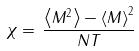Convert formula to latex. <formula><loc_0><loc_0><loc_500><loc_500>\chi = \, \frac { \left < M ^ { 2 } \right > - \left < M \right > ^ { 2 } } { N T }</formula> 